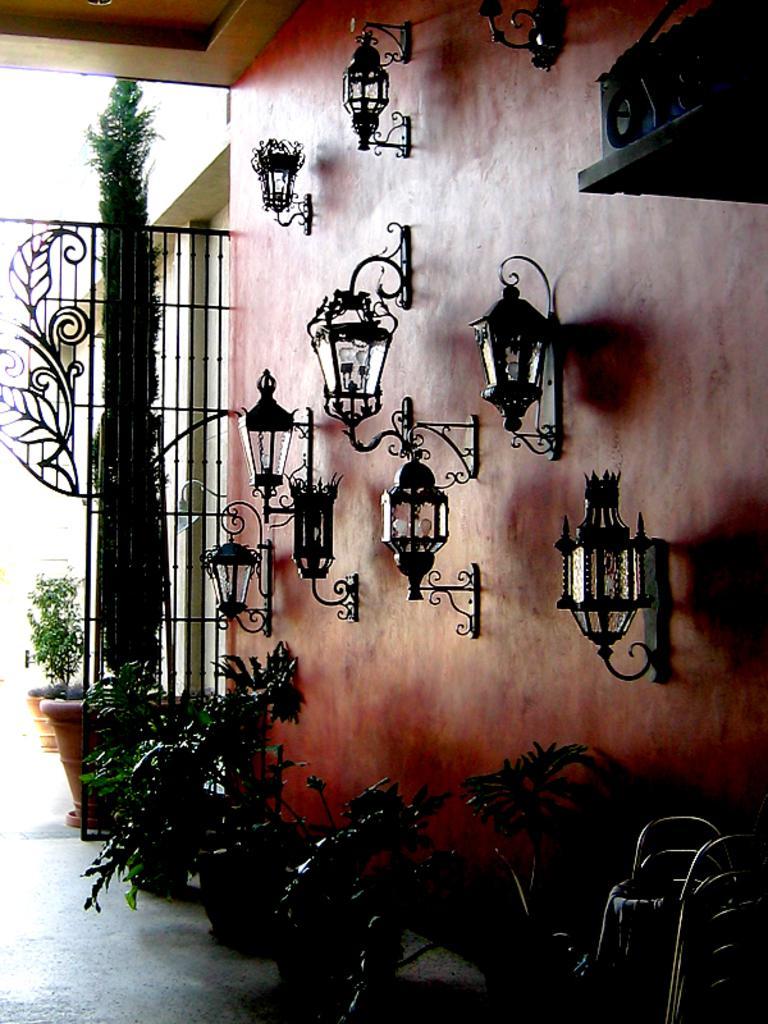Could you give a brief overview of what you see in this image? In the picture there are lights fit to the wall and in front of the wall there are few plants and in the background there is an iron grill, behind that there are two plants. 